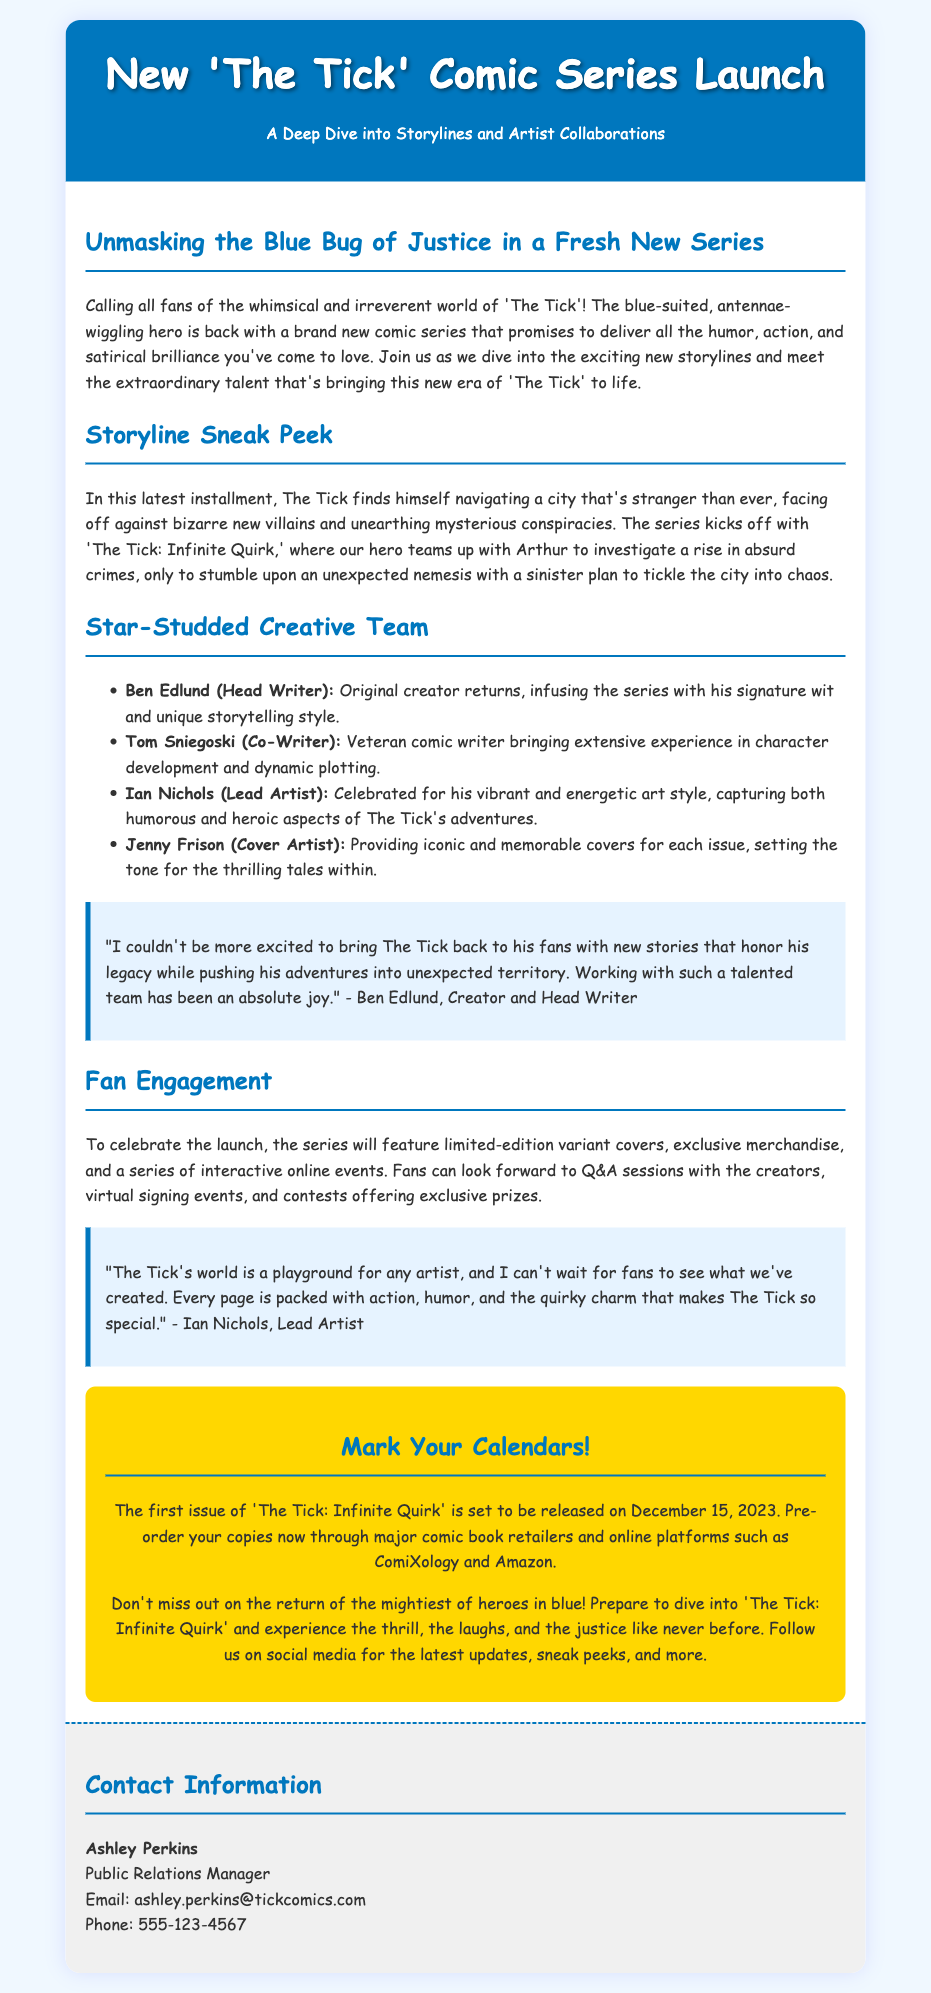What is the title of the new comic series? The title of the new comic series is provided in the header of the document.
Answer: The Tick: Infinite Quirk Who is the head writer of the new series? The head writer's name is mentioned under the creative team section.
Answer: Ben Edlund What is the release date of the first issue? The release date is stated in the call-to-action section at the end of the document.
Answer: December 15, 2023 What is the name of the lead artist? The lead artist is mentioned in the star-studded creative team list.
Answer: Ian Nichols Which character teams up with The Tick in the comic? The teaming character is noted in the storyline sneak peek section.
Answer: Arthur What type of events will fans participate in? The type of events is listed in the fan engagement section of the document.
Answer: Online events Who provides the iconic covers for the issues? The cover artist's name is included in the list of the creative team.
Answer: Jenny Frison What is the primary theme of the new series? The primary theme can be inferred from the description in the introduction and storyline sneak peek sections.
Answer: Humor and satire 